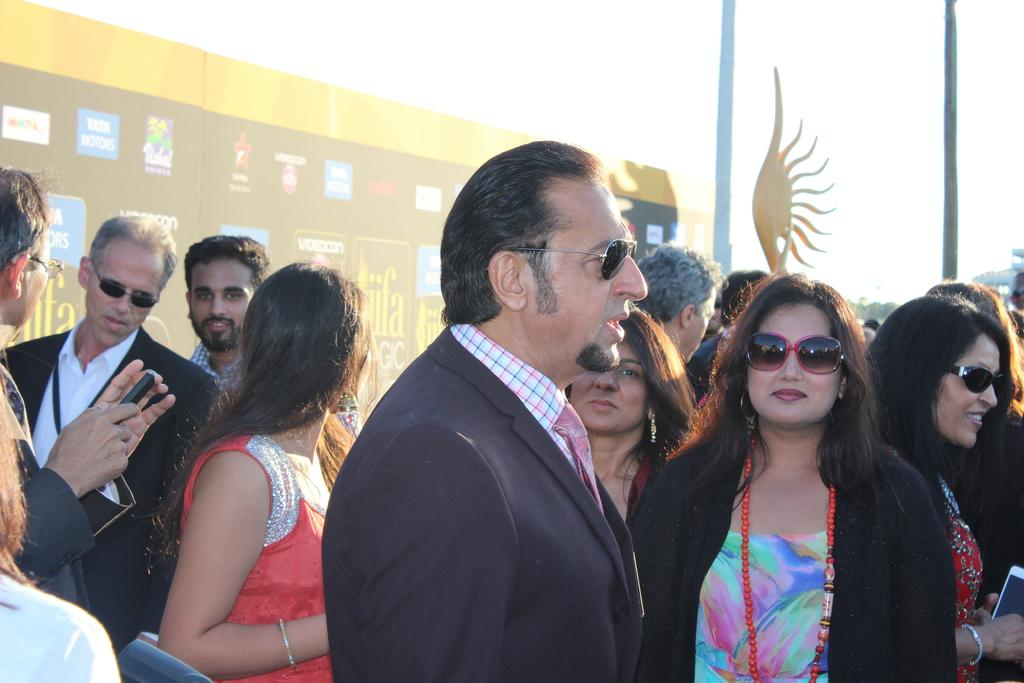What is the main subject of the image? The main subject of the image is a group of people. Can you describe the background of the image? There is a banner in the background of the image. What is visible at the top of the image? The sky is visible at the top of the image. What type of receipt can be seen in the hands of the dad in the image? There is no dad or receipt present in the image. 